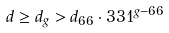Convert formula to latex. <formula><loc_0><loc_0><loc_500><loc_500>d \geq d _ { g } > d _ { 6 6 } \cdot 3 3 1 ^ { g - 6 6 }</formula> 